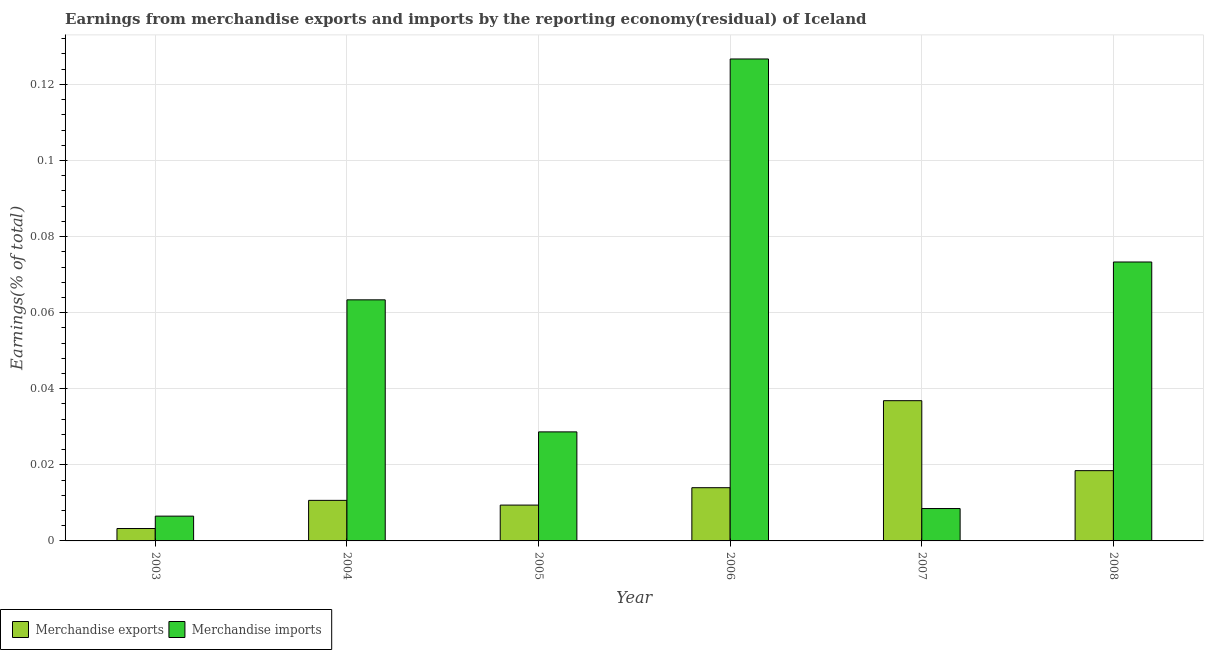How many different coloured bars are there?
Your answer should be compact. 2. Are the number of bars per tick equal to the number of legend labels?
Provide a short and direct response. Yes. Are the number of bars on each tick of the X-axis equal?
Your answer should be very brief. Yes. How many bars are there on the 1st tick from the left?
Give a very brief answer. 2. How many bars are there on the 5th tick from the right?
Offer a terse response. 2. What is the earnings from merchandise imports in 2003?
Your answer should be compact. 0.01. Across all years, what is the maximum earnings from merchandise imports?
Offer a very short reply. 0.13. Across all years, what is the minimum earnings from merchandise imports?
Offer a very short reply. 0.01. In which year was the earnings from merchandise imports maximum?
Provide a succinct answer. 2006. What is the total earnings from merchandise imports in the graph?
Give a very brief answer. 0.31. What is the difference between the earnings from merchandise imports in 2007 and that in 2008?
Give a very brief answer. -0.06. What is the difference between the earnings from merchandise exports in 2004 and the earnings from merchandise imports in 2007?
Your response must be concise. -0.03. What is the average earnings from merchandise imports per year?
Offer a terse response. 0.05. In how many years, is the earnings from merchandise exports greater than 0.04 %?
Offer a terse response. 0. What is the ratio of the earnings from merchandise imports in 2005 to that in 2008?
Your response must be concise. 0.39. Is the difference between the earnings from merchandise exports in 2003 and 2004 greater than the difference between the earnings from merchandise imports in 2003 and 2004?
Offer a terse response. No. What is the difference between the highest and the second highest earnings from merchandise imports?
Ensure brevity in your answer.  0.05. What is the difference between the highest and the lowest earnings from merchandise exports?
Make the answer very short. 0.03. What does the 2nd bar from the left in 2004 represents?
Give a very brief answer. Merchandise imports. What does the 2nd bar from the right in 2003 represents?
Your response must be concise. Merchandise exports. How many bars are there?
Offer a very short reply. 12. Are all the bars in the graph horizontal?
Your response must be concise. No. How many years are there in the graph?
Offer a terse response. 6. How are the legend labels stacked?
Your answer should be compact. Horizontal. What is the title of the graph?
Keep it short and to the point. Earnings from merchandise exports and imports by the reporting economy(residual) of Iceland. Does "current US$" appear as one of the legend labels in the graph?
Provide a succinct answer. No. What is the label or title of the X-axis?
Your answer should be very brief. Year. What is the label or title of the Y-axis?
Ensure brevity in your answer.  Earnings(% of total). What is the Earnings(% of total) in Merchandise exports in 2003?
Your response must be concise. 0. What is the Earnings(% of total) in Merchandise imports in 2003?
Give a very brief answer. 0.01. What is the Earnings(% of total) in Merchandise exports in 2004?
Ensure brevity in your answer.  0.01. What is the Earnings(% of total) of Merchandise imports in 2004?
Keep it short and to the point. 0.06. What is the Earnings(% of total) of Merchandise exports in 2005?
Your answer should be very brief. 0.01. What is the Earnings(% of total) in Merchandise imports in 2005?
Provide a short and direct response. 0.03. What is the Earnings(% of total) in Merchandise exports in 2006?
Keep it short and to the point. 0.01. What is the Earnings(% of total) of Merchandise imports in 2006?
Make the answer very short. 0.13. What is the Earnings(% of total) in Merchandise exports in 2007?
Ensure brevity in your answer.  0.04. What is the Earnings(% of total) of Merchandise imports in 2007?
Your response must be concise. 0.01. What is the Earnings(% of total) in Merchandise exports in 2008?
Offer a terse response. 0.02. What is the Earnings(% of total) of Merchandise imports in 2008?
Offer a terse response. 0.07. Across all years, what is the maximum Earnings(% of total) in Merchandise exports?
Provide a succinct answer. 0.04. Across all years, what is the maximum Earnings(% of total) of Merchandise imports?
Give a very brief answer. 0.13. Across all years, what is the minimum Earnings(% of total) in Merchandise exports?
Provide a succinct answer. 0. Across all years, what is the minimum Earnings(% of total) in Merchandise imports?
Keep it short and to the point. 0.01. What is the total Earnings(% of total) of Merchandise exports in the graph?
Offer a very short reply. 0.09. What is the total Earnings(% of total) of Merchandise imports in the graph?
Provide a short and direct response. 0.31. What is the difference between the Earnings(% of total) in Merchandise exports in 2003 and that in 2004?
Provide a succinct answer. -0.01. What is the difference between the Earnings(% of total) in Merchandise imports in 2003 and that in 2004?
Provide a short and direct response. -0.06. What is the difference between the Earnings(% of total) of Merchandise exports in 2003 and that in 2005?
Provide a short and direct response. -0.01. What is the difference between the Earnings(% of total) in Merchandise imports in 2003 and that in 2005?
Keep it short and to the point. -0.02. What is the difference between the Earnings(% of total) of Merchandise exports in 2003 and that in 2006?
Your answer should be compact. -0.01. What is the difference between the Earnings(% of total) of Merchandise imports in 2003 and that in 2006?
Your response must be concise. -0.12. What is the difference between the Earnings(% of total) in Merchandise exports in 2003 and that in 2007?
Provide a short and direct response. -0.03. What is the difference between the Earnings(% of total) in Merchandise imports in 2003 and that in 2007?
Ensure brevity in your answer.  -0. What is the difference between the Earnings(% of total) of Merchandise exports in 2003 and that in 2008?
Offer a terse response. -0.02. What is the difference between the Earnings(% of total) in Merchandise imports in 2003 and that in 2008?
Keep it short and to the point. -0.07. What is the difference between the Earnings(% of total) in Merchandise exports in 2004 and that in 2005?
Provide a succinct answer. 0. What is the difference between the Earnings(% of total) in Merchandise imports in 2004 and that in 2005?
Offer a terse response. 0.03. What is the difference between the Earnings(% of total) in Merchandise exports in 2004 and that in 2006?
Your response must be concise. -0. What is the difference between the Earnings(% of total) in Merchandise imports in 2004 and that in 2006?
Make the answer very short. -0.06. What is the difference between the Earnings(% of total) of Merchandise exports in 2004 and that in 2007?
Provide a succinct answer. -0.03. What is the difference between the Earnings(% of total) of Merchandise imports in 2004 and that in 2007?
Offer a very short reply. 0.05. What is the difference between the Earnings(% of total) in Merchandise exports in 2004 and that in 2008?
Keep it short and to the point. -0.01. What is the difference between the Earnings(% of total) of Merchandise imports in 2004 and that in 2008?
Your answer should be compact. -0.01. What is the difference between the Earnings(% of total) in Merchandise exports in 2005 and that in 2006?
Your answer should be compact. -0. What is the difference between the Earnings(% of total) of Merchandise imports in 2005 and that in 2006?
Offer a very short reply. -0.1. What is the difference between the Earnings(% of total) in Merchandise exports in 2005 and that in 2007?
Offer a terse response. -0.03. What is the difference between the Earnings(% of total) in Merchandise imports in 2005 and that in 2007?
Your response must be concise. 0.02. What is the difference between the Earnings(% of total) of Merchandise exports in 2005 and that in 2008?
Provide a succinct answer. -0.01. What is the difference between the Earnings(% of total) in Merchandise imports in 2005 and that in 2008?
Offer a terse response. -0.04. What is the difference between the Earnings(% of total) in Merchandise exports in 2006 and that in 2007?
Your answer should be compact. -0.02. What is the difference between the Earnings(% of total) of Merchandise imports in 2006 and that in 2007?
Make the answer very short. 0.12. What is the difference between the Earnings(% of total) in Merchandise exports in 2006 and that in 2008?
Your answer should be very brief. -0. What is the difference between the Earnings(% of total) in Merchandise imports in 2006 and that in 2008?
Your answer should be compact. 0.05. What is the difference between the Earnings(% of total) of Merchandise exports in 2007 and that in 2008?
Provide a succinct answer. 0.02. What is the difference between the Earnings(% of total) of Merchandise imports in 2007 and that in 2008?
Provide a short and direct response. -0.06. What is the difference between the Earnings(% of total) of Merchandise exports in 2003 and the Earnings(% of total) of Merchandise imports in 2004?
Provide a short and direct response. -0.06. What is the difference between the Earnings(% of total) in Merchandise exports in 2003 and the Earnings(% of total) in Merchandise imports in 2005?
Keep it short and to the point. -0.03. What is the difference between the Earnings(% of total) of Merchandise exports in 2003 and the Earnings(% of total) of Merchandise imports in 2006?
Ensure brevity in your answer.  -0.12. What is the difference between the Earnings(% of total) in Merchandise exports in 2003 and the Earnings(% of total) in Merchandise imports in 2007?
Your answer should be compact. -0.01. What is the difference between the Earnings(% of total) of Merchandise exports in 2003 and the Earnings(% of total) of Merchandise imports in 2008?
Your answer should be very brief. -0.07. What is the difference between the Earnings(% of total) of Merchandise exports in 2004 and the Earnings(% of total) of Merchandise imports in 2005?
Ensure brevity in your answer.  -0.02. What is the difference between the Earnings(% of total) of Merchandise exports in 2004 and the Earnings(% of total) of Merchandise imports in 2006?
Offer a very short reply. -0.12. What is the difference between the Earnings(% of total) of Merchandise exports in 2004 and the Earnings(% of total) of Merchandise imports in 2007?
Your response must be concise. 0. What is the difference between the Earnings(% of total) in Merchandise exports in 2004 and the Earnings(% of total) in Merchandise imports in 2008?
Your answer should be compact. -0.06. What is the difference between the Earnings(% of total) in Merchandise exports in 2005 and the Earnings(% of total) in Merchandise imports in 2006?
Make the answer very short. -0.12. What is the difference between the Earnings(% of total) in Merchandise exports in 2005 and the Earnings(% of total) in Merchandise imports in 2007?
Give a very brief answer. 0. What is the difference between the Earnings(% of total) of Merchandise exports in 2005 and the Earnings(% of total) of Merchandise imports in 2008?
Your answer should be very brief. -0.06. What is the difference between the Earnings(% of total) in Merchandise exports in 2006 and the Earnings(% of total) in Merchandise imports in 2007?
Offer a very short reply. 0.01. What is the difference between the Earnings(% of total) of Merchandise exports in 2006 and the Earnings(% of total) of Merchandise imports in 2008?
Your answer should be compact. -0.06. What is the difference between the Earnings(% of total) in Merchandise exports in 2007 and the Earnings(% of total) in Merchandise imports in 2008?
Give a very brief answer. -0.04. What is the average Earnings(% of total) of Merchandise exports per year?
Give a very brief answer. 0.02. What is the average Earnings(% of total) of Merchandise imports per year?
Your answer should be compact. 0.05. In the year 2003, what is the difference between the Earnings(% of total) of Merchandise exports and Earnings(% of total) of Merchandise imports?
Keep it short and to the point. -0. In the year 2004, what is the difference between the Earnings(% of total) of Merchandise exports and Earnings(% of total) of Merchandise imports?
Give a very brief answer. -0.05. In the year 2005, what is the difference between the Earnings(% of total) in Merchandise exports and Earnings(% of total) in Merchandise imports?
Provide a succinct answer. -0.02. In the year 2006, what is the difference between the Earnings(% of total) in Merchandise exports and Earnings(% of total) in Merchandise imports?
Offer a very short reply. -0.11. In the year 2007, what is the difference between the Earnings(% of total) in Merchandise exports and Earnings(% of total) in Merchandise imports?
Provide a short and direct response. 0.03. In the year 2008, what is the difference between the Earnings(% of total) of Merchandise exports and Earnings(% of total) of Merchandise imports?
Offer a very short reply. -0.05. What is the ratio of the Earnings(% of total) of Merchandise exports in 2003 to that in 2004?
Offer a terse response. 0.31. What is the ratio of the Earnings(% of total) of Merchandise imports in 2003 to that in 2004?
Your answer should be very brief. 0.1. What is the ratio of the Earnings(% of total) of Merchandise exports in 2003 to that in 2005?
Your response must be concise. 0.35. What is the ratio of the Earnings(% of total) in Merchandise imports in 2003 to that in 2005?
Your answer should be very brief. 0.23. What is the ratio of the Earnings(% of total) of Merchandise exports in 2003 to that in 2006?
Give a very brief answer. 0.23. What is the ratio of the Earnings(% of total) of Merchandise imports in 2003 to that in 2006?
Provide a short and direct response. 0.05. What is the ratio of the Earnings(% of total) of Merchandise exports in 2003 to that in 2007?
Ensure brevity in your answer.  0.09. What is the ratio of the Earnings(% of total) in Merchandise imports in 2003 to that in 2007?
Keep it short and to the point. 0.77. What is the ratio of the Earnings(% of total) of Merchandise exports in 2003 to that in 2008?
Offer a terse response. 0.18. What is the ratio of the Earnings(% of total) of Merchandise imports in 2003 to that in 2008?
Make the answer very short. 0.09. What is the ratio of the Earnings(% of total) in Merchandise exports in 2004 to that in 2005?
Offer a very short reply. 1.13. What is the ratio of the Earnings(% of total) of Merchandise imports in 2004 to that in 2005?
Offer a very short reply. 2.21. What is the ratio of the Earnings(% of total) of Merchandise exports in 2004 to that in 2006?
Make the answer very short. 0.76. What is the ratio of the Earnings(% of total) of Merchandise imports in 2004 to that in 2006?
Offer a very short reply. 0.5. What is the ratio of the Earnings(% of total) of Merchandise exports in 2004 to that in 2007?
Ensure brevity in your answer.  0.29. What is the ratio of the Earnings(% of total) of Merchandise imports in 2004 to that in 2007?
Your response must be concise. 7.44. What is the ratio of the Earnings(% of total) of Merchandise exports in 2004 to that in 2008?
Your response must be concise. 0.58. What is the ratio of the Earnings(% of total) of Merchandise imports in 2004 to that in 2008?
Provide a succinct answer. 0.86. What is the ratio of the Earnings(% of total) of Merchandise exports in 2005 to that in 2006?
Provide a succinct answer. 0.67. What is the ratio of the Earnings(% of total) of Merchandise imports in 2005 to that in 2006?
Offer a very short reply. 0.23. What is the ratio of the Earnings(% of total) in Merchandise exports in 2005 to that in 2007?
Your response must be concise. 0.26. What is the ratio of the Earnings(% of total) in Merchandise imports in 2005 to that in 2007?
Offer a very short reply. 3.37. What is the ratio of the Earnings(% of total) of Merchandise exports in 2005 to that in 2008?
Your answer should be very brief. 0.51. What is the ratio of the Earnings(% of total) of Merchandise imports in 2005 to that in 2008?
Keep it short and to the point. 0.39. What is the ratio of the Earnings(% of total) of Merchandise exports in 2006 to that in 2007?
Keep it short and to the point. 0.38. What is the ratio of the Earnings(% of total) in Merchandise imports in 2006 to that in 2007?
Your answer should be very brief. 14.88. What is the ratio of the Earnings(% of total) in Merchandise exports in 2006 to that in 2008?
Your answer should be very brief. 0.76. What is the ratio of the Earnings(% of total) in Merchandise imports in 2006 to that in 2008?
Ensure brevity in your answer.  1.73. What is the ratio of the Earnings(% of total) of Merchandise exports in 2007 to that in 2008?
Offer a very short reply. 2. What is the ratio of the Earnings(% of total) of Merchandise imports in 2007 to that in 2008?
Provide a succinct answer. 0.12. What is the difference between the highest and the second highest Earnings(% of total) in Merchandise exports?
Your response must be concise. 0.02. What is the difference between the highest and the second highest Earnings(% of total) in Merchandise imports?
Ensure brevity in your answer.  0.05. What is the difference between the highest and the lowest Earnings(% of total) in Merchandise exports?
Offer a very short reply. 0.03. What is the difference between the highest and the lowest Earnings(% of total) in Merchandise imports?
Your response must be concise. 0.12. 